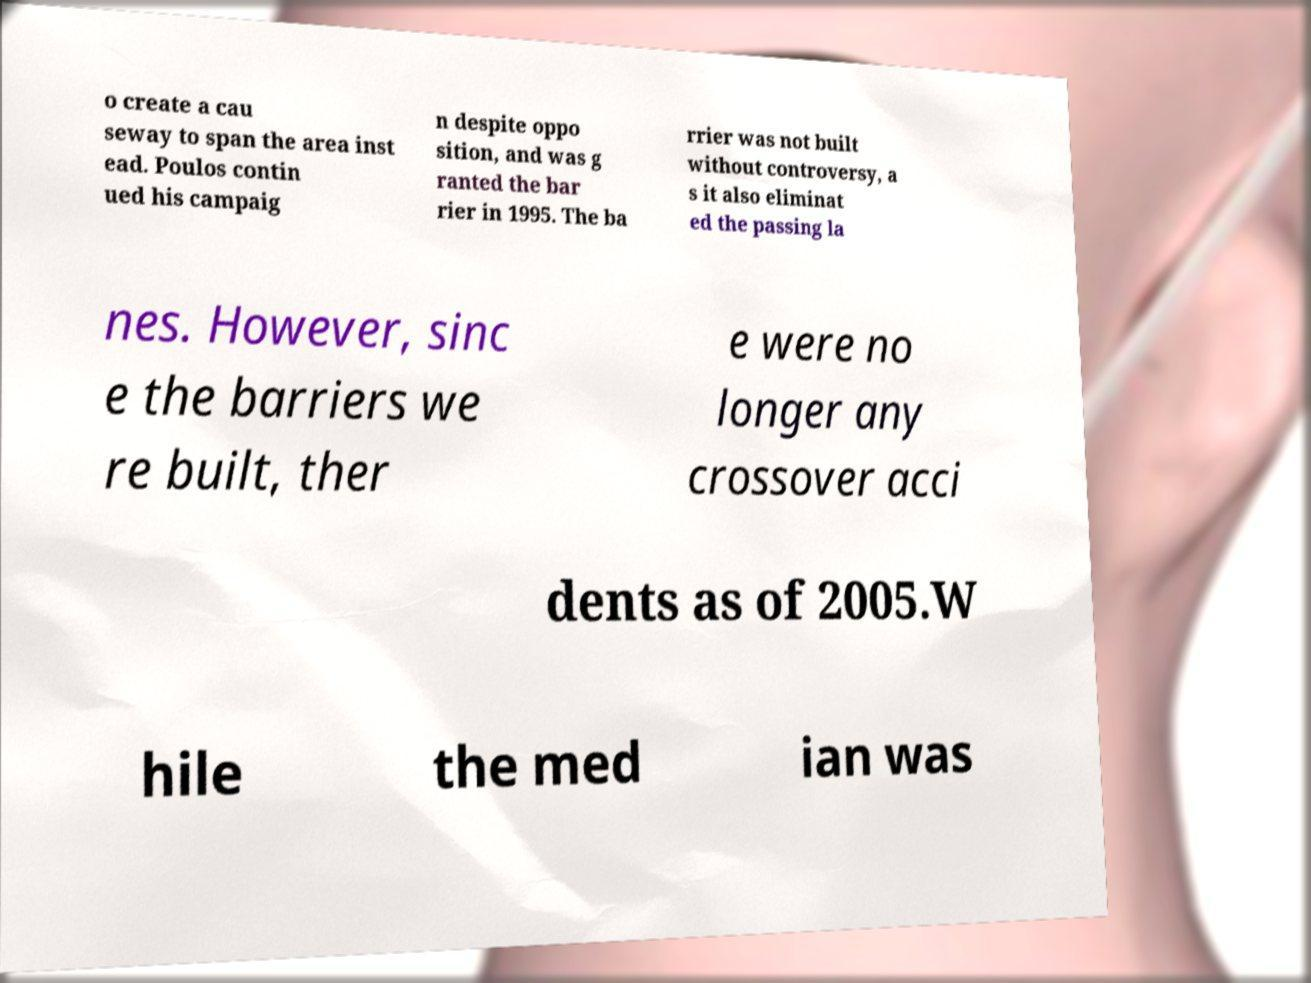I need the written content from this picture converted into text. Can you do that? o create a cau seway to span the area inst ead. Poulos contin ued his campaig n despite oppo sition, and was g ranted the bar rier in 1995. The ba rrier was not built without controversy, a s it also eliminat ed the passing la nes. However, sinc e the barriers we re built, ther e were no longer any crossover acci dents as of 2005.W hile the med ian was 